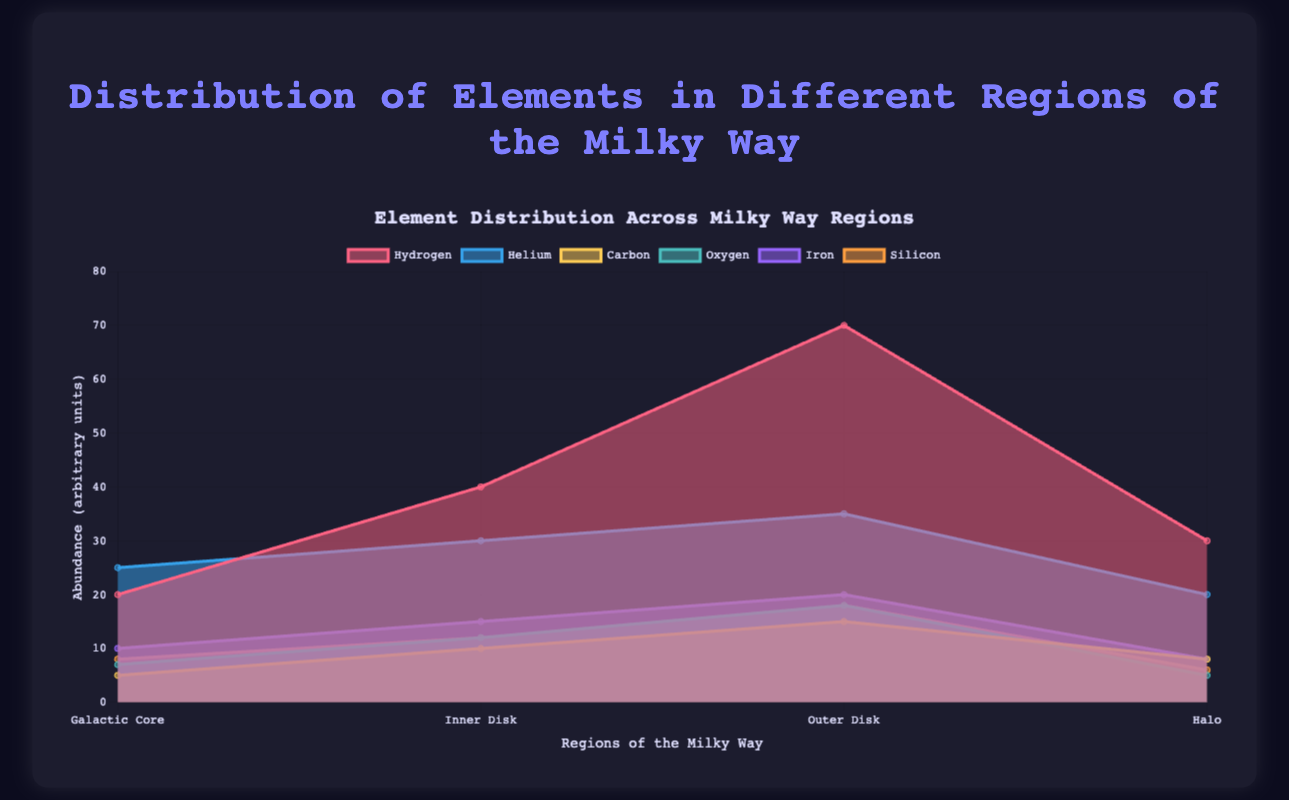What is the title of the chart? The title is displayed in a prominent position at the top of the chart in bold text. Observing the title text directly provides the answer.
Answer: Distribution of Elements in Different Regions of the Milky Way Which region contains the most Hydrogen? By examining the Hydrogen data points for all regions, we see that the Outer Disk has the highest Hydrogen value of 70.
Answer: Outer Disk Compare the abundance of Helium in the Galactic Core and Inner Disk. Which is higher and by how much? By looking at the Helium data for the Galactic Core (25) and Inner Disk (30), we subtract the smaller value from the larger one: 30 - 25 = 5. Helium is higher in the Inner Disk by 5 units.
Answer: Inner Disk, by 5 What is the average abundance of Oxygen across all regions? Summing up the values of Oxygen (7 + 12 + 18 + 5) equals 42. There are 4 regions, so 42/4 = 10.5.
Answer: 10.5 Which element shows the least variation in abundance across all regions? To determine this, we compare the ranges of each element. Hydrogen (70-20=50), Helium (35-20=15), Carbon (15-5=10), Oxygen (18-5=13), Iron (20-8=12), and Silicon (18-6=12). Carbon, with the range of 10, shows the least variation.
Answer: Carbon How does the abundance of Iron in the Inner Disk compare to the Halo? The Iron abundance in the Inner Disk is 15, while in the Halo, it is 8. Thus, the Iron abundance in the Inner Disk is higher than in the Halo.
Answer: The Inner Disk has more Iron than the Halo What is the sum of the Silicon abundance values across all regions? Adding the Silicon values for all regions (8 + 12 + 18 + 6) results in 44.
Answer: 44 Between which two regions is the abundance of Hydrogen most similar? By comparing Hydrogen values: 20 (Galactic Core), 40 (Inner Disk), 70 (Outer Disk), and 30 (Halo), the closest pair is 40 (Inner Disk) and 30 (Halo), differing by only 10 units.
Answer: Inner Disk and Halo Which element has the highest total abundance across all regions? Summing all values for each element: Hydrogen (20+40+70+30=160), Helium (25+30+35+20=110), Carbon (5+10+15+8=38), Oxygen (7+12+18+5=42), Iron (10+15+20+8=53), Silicon (8+12+18+6=44). Hydrogen, with a total of 160, has the highest abundance.
Answer: Hydrogen Why is the usage of an area chart appropriate for this data? An area chart is suitable for depicting the cumulative distribution and comparisons of different elements across regions. It effectively illustrates trends and relationships among the various elements over regions.
Answer: Shows cumulative distribution and comparisons effectively 